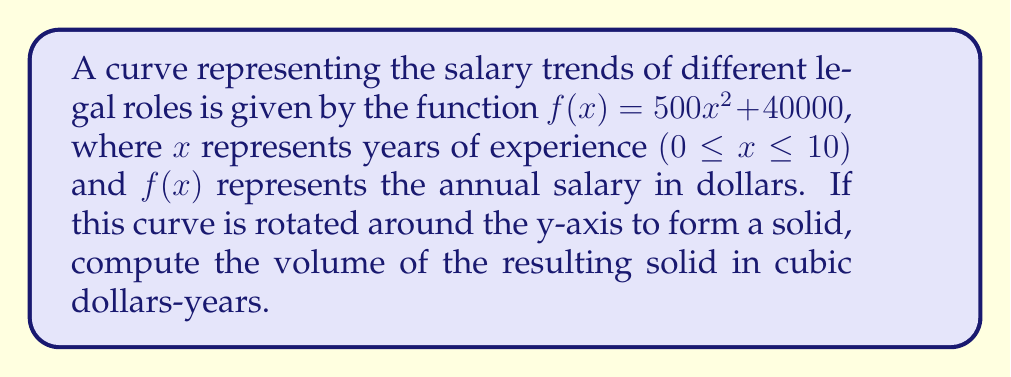Could you help me with this problem? To solve this problem, we'll use the shell method for calculating the volume of a solid of revolution. The steps are as follows:

1) The shell method formula for rotating around the y-axis is:

   $$V = 2\pi \int_a^b xf(x)dx$$

2) In this case, $a = 0$, $b = 10$, and $f(x) = 500x^2 + 40000$

3) Substituting these into the formula:

   $$V = 2\pi \int_0^{10} x(500x^2 + 40000)dx$$

4) Distribute $x$ inside the parentheses:

   $$V = 2\pi \int_0^{10} (500x^3 + 40000x)dx$$

5) Integrate:

   $$V = 2\pi [\frac{500x^4}{4} + \frac{40000x^2}{2}]_0^{10}$$

6) Evaluate the integral:

   $$V = 2\pi [\frac{500(10^4)}{4} + \frac{40000(10^2)}{2} - (\frac{500(0^4)}{4} + \frac{40000(0^2)}{2})]$$

7) Simplify:

   $$V = 2\pi [1250000 + 2000000]$$
   $$V = 2\pi (3250000)$$
   $$V = 6500000\pi$$

8) The final result is in cubic dollars-years.
Answer: $6500000\pi$ cubic dollars-years 